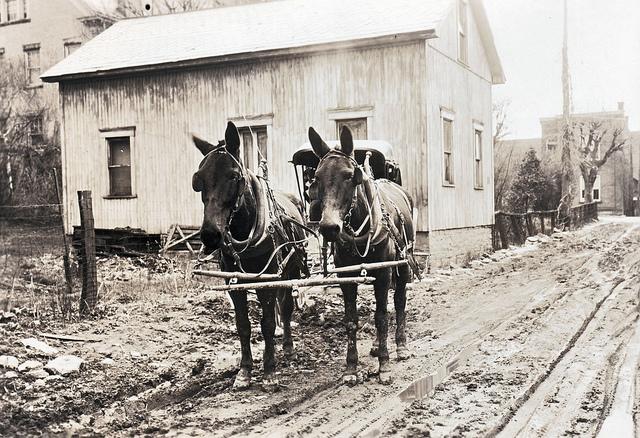Is this an old photo?
Write a very short answer. Yes. Is there any color in this photo?
Concise answer only. No. Could these be mules?
Write a very short answer. Yes. 